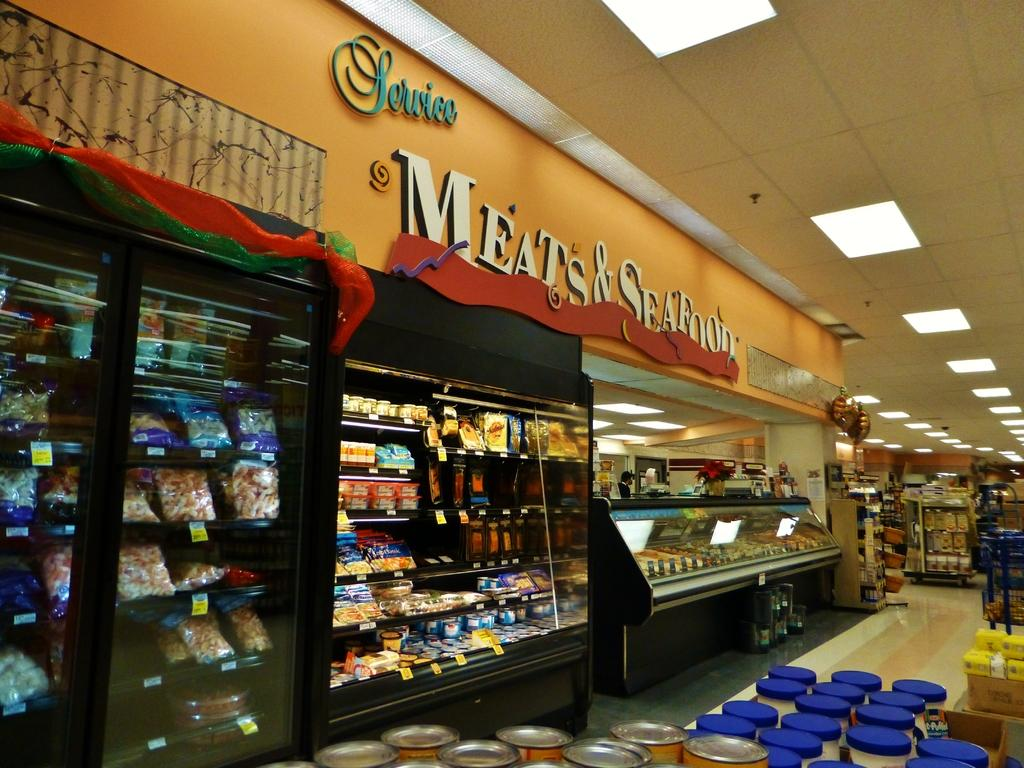<image>
Present a compact description of the photo's key features. The Meats & Seafood counters are mostly stocked. 